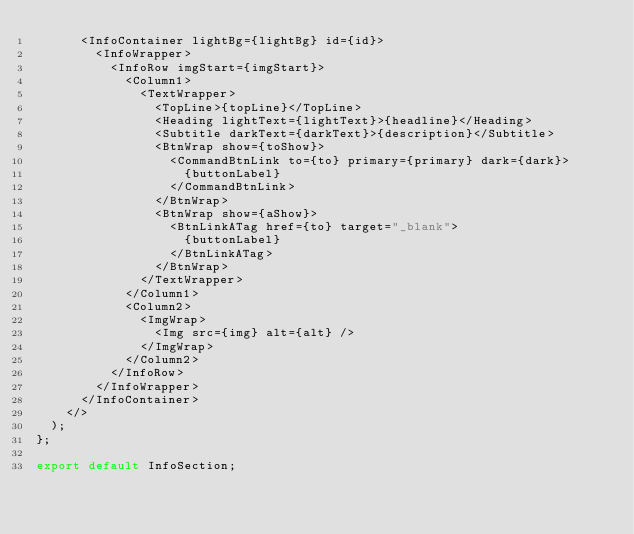<code> <loc_0><loc_0><loc_500><loc_500><_JavaScript_>      <InfoContainer lightBg={lightBg} id={id}>
        <InfoWrapper>
          <InfoRow imgStart={imgStart}>
            <Column1>
              <TextWrapper>
                <TopLine>{topLine}</TopLine>
                <Heading lightText={lightText}>{headline}</Heading>
                <Subtitle darkText={darkText}>{description}</Subtitle>
                <BtnWrap show={toShow}>
                  <CommandBtnLink to={to} primary={primary} dark={dark}>
                    {buttonLabel}
                  </CommandBtnLink>
                </BtnWrap>
                <BtnWrap show={aShow}>
                  <BtnLinkATag href={to} target="_blank">
                    {buttonLabel}
                  </BtnLinkATag>
                </BtnWrap>
              </TextWrapper>
            </Column1>
            <Column2>
              <ImgWrap>
                <Img src={img} alt={alt} />
              </ImgWrap>
            </Column2>
          </InfoRow>
        </InfoWrapper>
      </InfoContainer>
    </>
  );
};

export default InfoSection;
</code> 